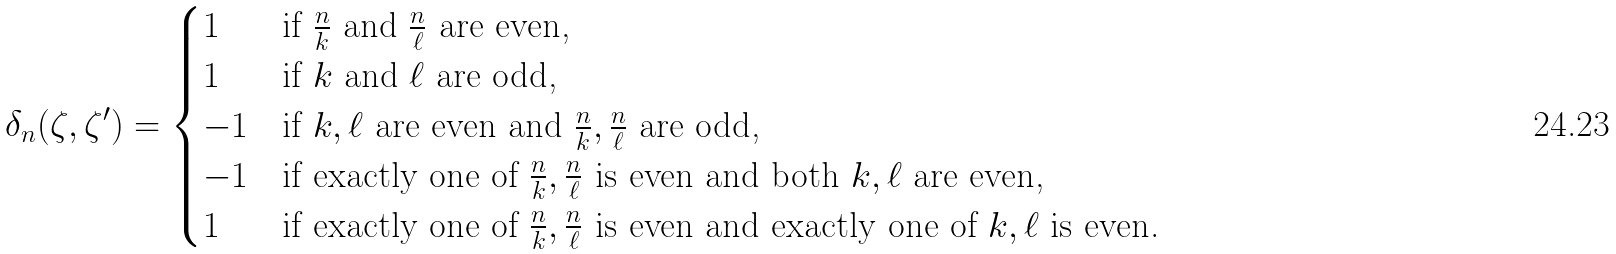Convert formula to latex. <formula><loc_0><loc_0><loc_500><loc_500>\delta _ { n } ( \zeta , \zeta ^ { \prime } ) = \begin{cases} 1 & \text {if $\frac{n}{k}$ and $\frac{n}{\ell}$ are even,} \\ 1 & \text {if $k$ and $\ell$ are odd,} \\ - 1 & \text {if $k, \ell$ are even and $\frac{n}{k}, \frac{n}{\ell}$ are odd,} \\ - 1 & \text {if exactly one of $\frac{n}{k},\frac{n}{\ell}$ is even and both $k, \ell$ are even,} \\ 1 & \text {if exactly one of $\frac{n}{k}, \frac{n}{\ell}$ is even and exactly one of $k, \ell$ is even.} \end{cases}</formula> 